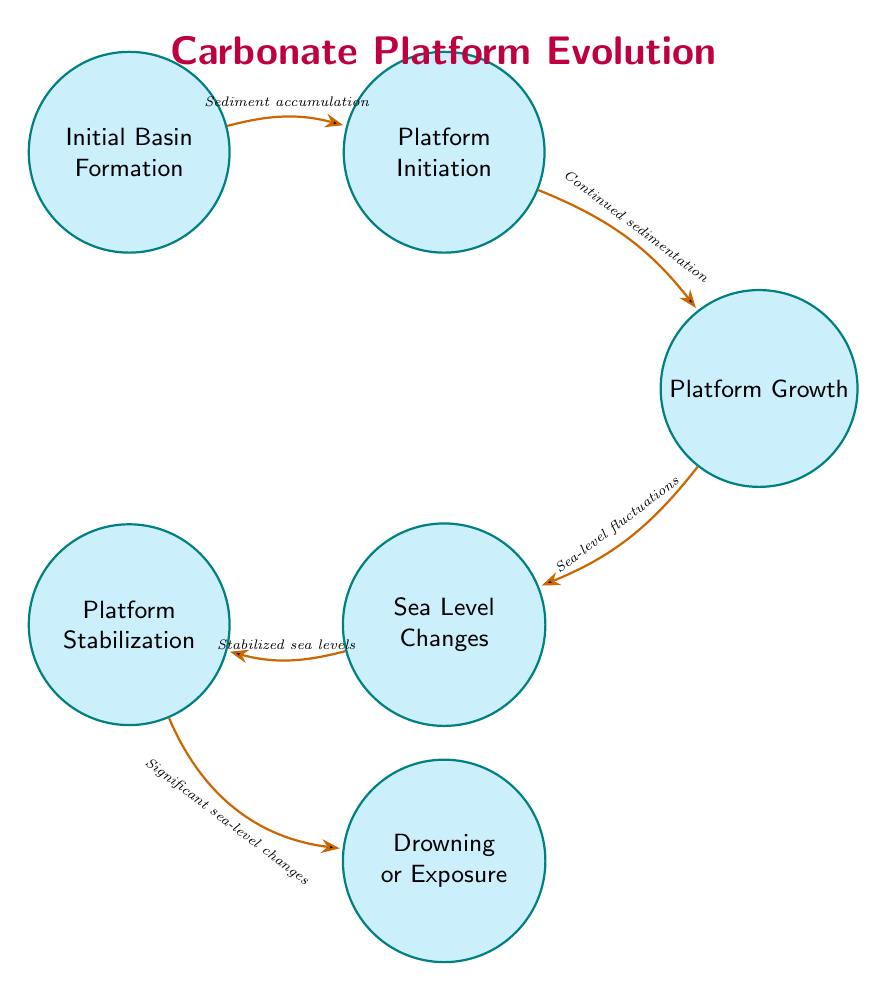What is the first state in the diagram? The first state listed in the diagram is "Initial Basin Formation." It is the starting point of the finite state machine and indicates where the process begins.
Answer: Initial Basin Formation How many states are present in the diagram? The diagram has a total of six states, each representing a distinct stage in carbonate platform evolution.
Answer: 6 What transition occurs between "Platform Initiation" and "Platform Growth"? The transition from "Platform Initiation" to "Platform Growth" is described as "Continued sedimentation," which indicates that sediment continues to accumulate, leading to the growth of the platform.
Answer: Continued sedimentation Which state follows "Sea Level Changes"? The state that follows "Sea Level Changes" in the diagram is "Platform Stabilization," suggesting that after changes in sea level, the platform reaches a stable condition.
Answer: Platform Stabilization What are the two possible outcomes after "Platform Stabilization"? After "Platform Stabilization," the possible outcomes are "Drowning" or "Exposure," depending on significant changes in sea level.
Answer: Drowning or Exposure What is the first transition described in the diagram? The first transition in the diagram is from "Initial Basin Formation" to "Platform Initiation," which occurs when sediment accumulation begins due to increased biological activity.
Answer: Sediment accumulation Explain how "Platform Growth" relates to "Sea Level Changes." "Platform Growth" is followed by "Sea Level Changes," indicating that the growth of the carbonate platform is influenced by fluctuations in sea level, which can affect the depositional environment.
Answer: Growth influenced by fluctuations Identify the state characterized by biogenic material accumulation. The state characterized by biogenic material accumulation is "Platform Initiation," where organisms like corals and algae contribute to forming the carbonate material of the platform.
Answer: Platform Initiation How does "Drowning or Exposure" manifest in the diagram? "Drowning or Exposure" manifests as the outcome of significant sea-level changes, showing the drastic shift either towards submerging the platform or exposing it to erosion.
Answer: Significant sea-level changes 